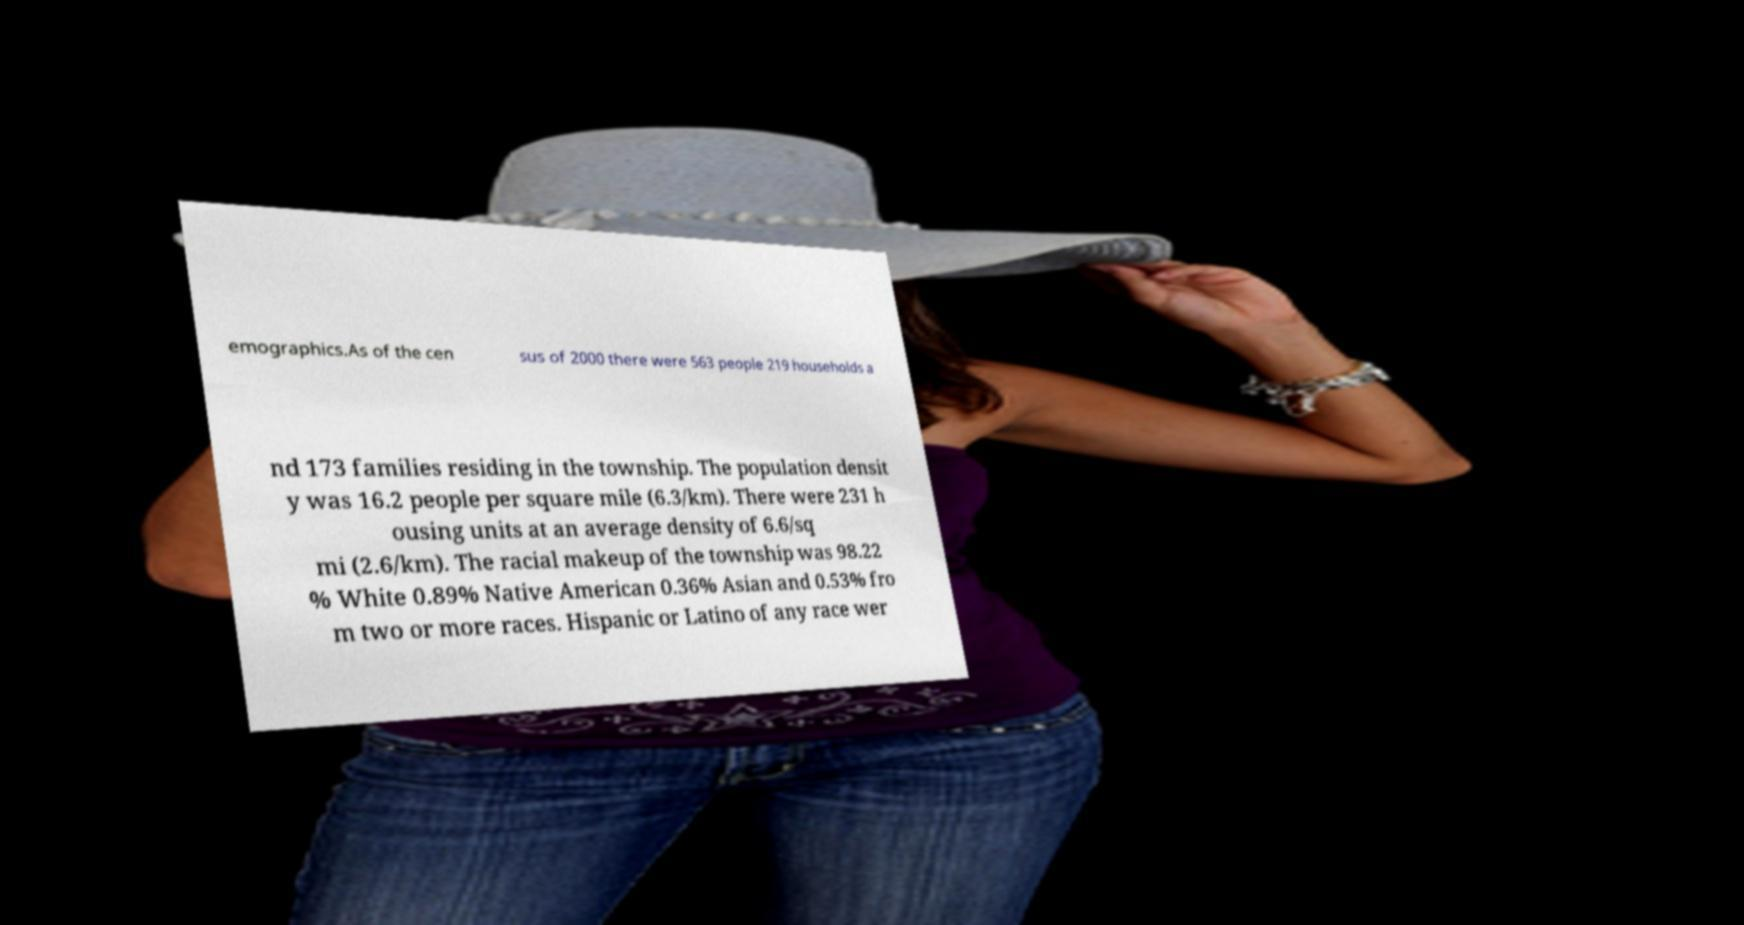There's text embedded in this image that I need extracted. Can you transcribe it verbatim? emographics.As of the cen sus of 2000 there were 563 people 219 households a nd 173 families residing in the township. The population densit y was 16.2 people per square mile (6.3/km). There were 231 h ousing units at an average density of 6.6/sq mi (2.6/km). The racial makeup of the township was 98.22 % White 0.89% Native American 0.36% Asian and 0.53% fro m two or more races. Hispanic or Latino of any race wer 